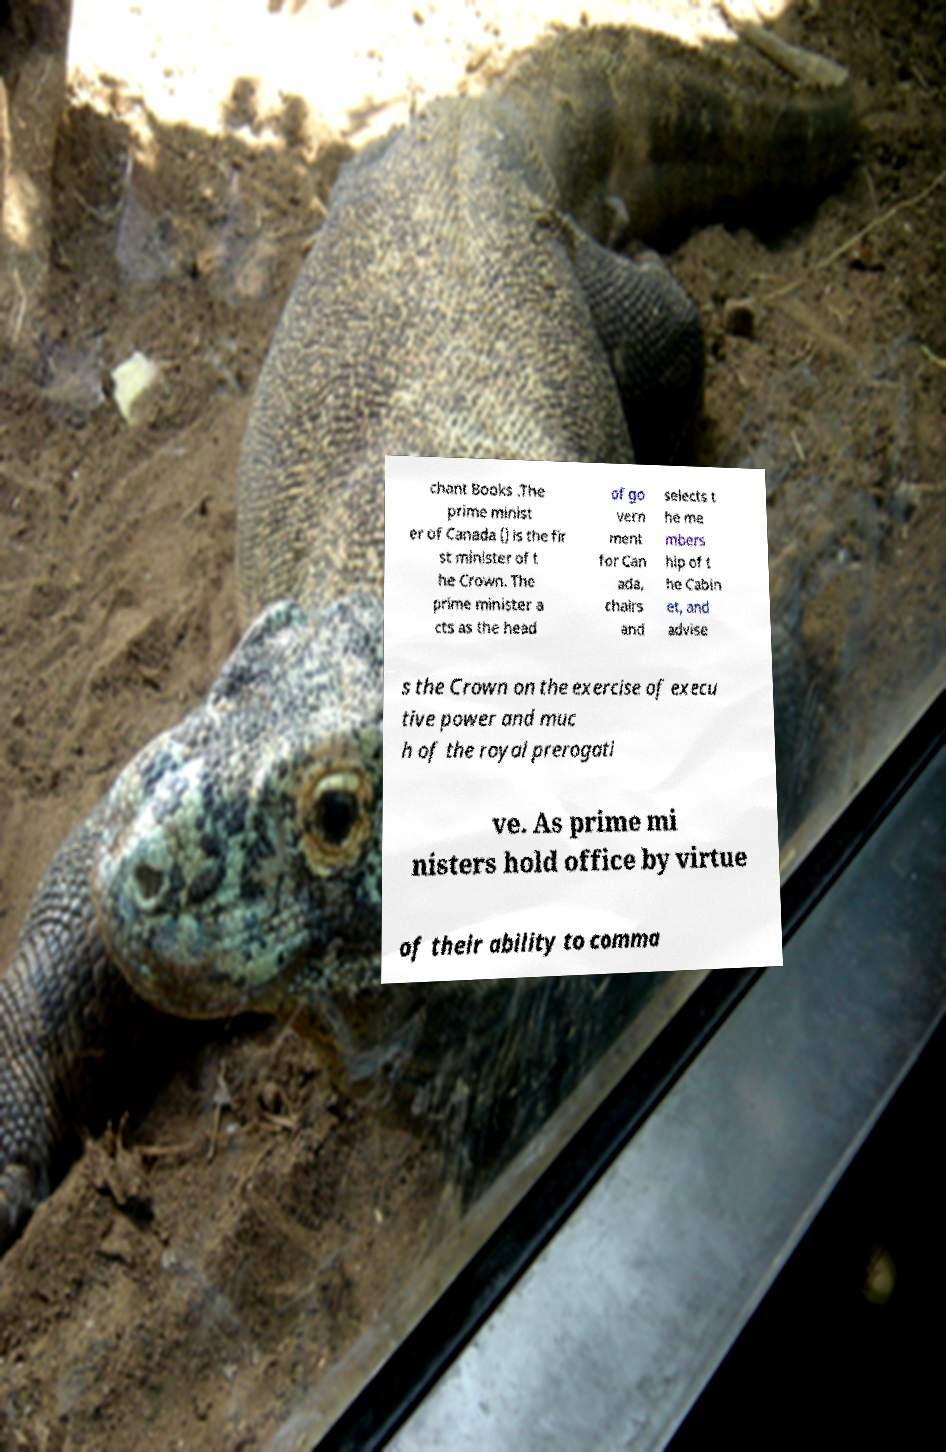For documentation purposes, I need the text within this image transcribed. Could you provide that? chant Books .The prime minist er of Canada () is the fir st minister of t he Crown. The prime minister a cts as the head of go vern ment for Can ada, chairs and selects t he me mbers hip of t he Cabin et, and advise s the Crown on the exercise of execu tive power and muc h of the royal prerogati ve. As prime mi nisters hold office by virtue of their ability to comma 